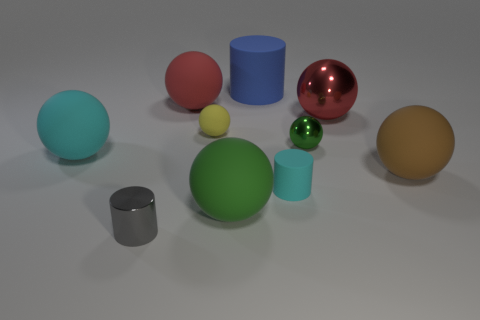Subtract 4 spheres. How many spheres are left? 3 Subtract all brown balls. How many balls are left? 6 Subtract all metallic spheres. How many spheres are left? 5 Subtract all red balls. Subtract all green cubes. How many balls are left? 5 Subtract all balls. How many objects are left? 3 Subtract all small blue matte balls. Subtract all big matte balls. How many objects are left? 6 Add 6 blue matte things. How many blue matte things are left? 7 Add 3 small blocks. How many small blocks exist? 3 Subtract 0 gray blocks. How many objects are left? 10 